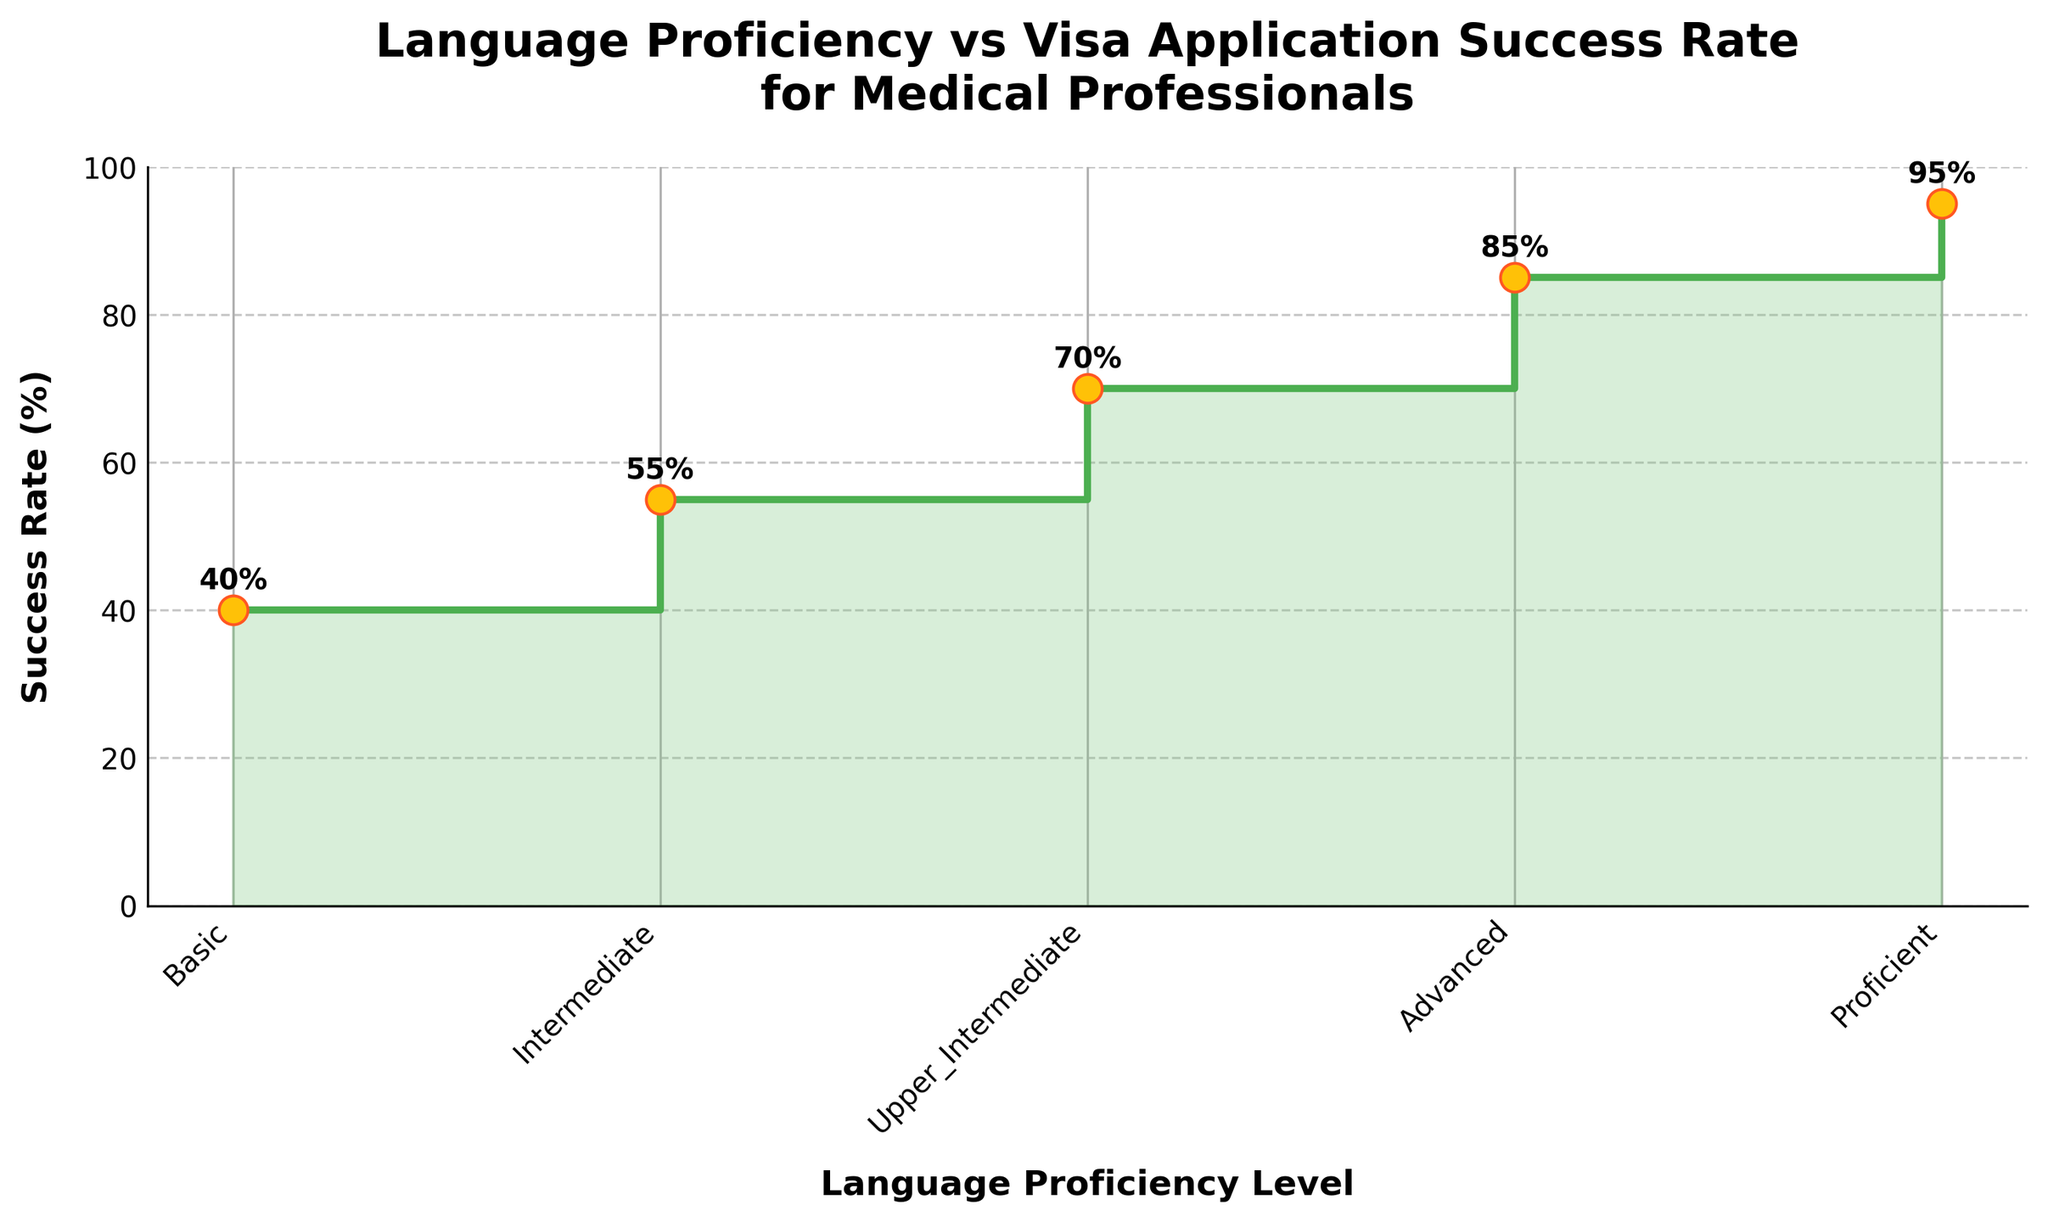What's the title of the figure? The title is prominently displayed at the top of the figure. It summarizes the subject of the plot.
Answer: Language Proficiency vs Visa Application Success Rate for Medical Professionals What is the success rate for Advanced proficiency? Locate the "Advanced" level on the x-axis and find its corresponding point on the y-axis. Read the success rate value next to it.
Answer: 85% How many proficiency levels are depicted in the figure? Count the number of unique labels on the x-axis representing different proficiency levels.
Answer: 5 Which proficiency level shows the highest success rate? Compare all the values on the y-axis and determine which label on the x-axis corresponds to the highest value.
Answer: Proficient What is the difference in success rate between Basic and Proficient levels? Subtract the success rate for Basic from the success rate for Proficient. The values are 95% for Proficient and 40% for Basic.
Answer: 55% What's the sum of the success rates for Basic and Intermediate levels? Add the success rates of Basic (40%) and Intermediate (55%). The sum is 40 + 55.
Answer: 95% Is the success rate difference between Intermediate and Upper Intermediate more than 10%? Calculate the difference between the success rates of Intermediate (55%) and Upper Intermediate (70%). The difference is 70 - 55. Compare this difference to 10%.
Answer: Yes Which two proficiency levels have a difference in success rates equal to 25%? Analyze the success rates for pairs of proficiency levels and find two levels where the difference in their success rates equals 25%. Basic (40%) and Intermediate (55%) gives 55 - 40 = 15, Intermediate (55%) and Upper Intermediate (70%) gives 70 - 55 = 15, Upper Intermediate (70%) and Advanced (85%) gives 85 - 70 = 15, Advanced (85%) and Proficient (95%) gives 95 - 85 = 10. Thus, no levels have a difference of 25%.
Answer: None What is the average success rate across all proficiency levels? Sum the success rates for all proficiency levels (40 + 55 + 70 + 85 + 95) and divide by the number of levels (5). The total is 345, so the average is 345 / 5.
Answer: 69% Does the plot show a positive or negative trend in success rates with increasing proficiency levels? Observe the direction of the steps in the plot. The success rate increases as proficiency level increases, indicating a positive trend.
Answer: Positive 